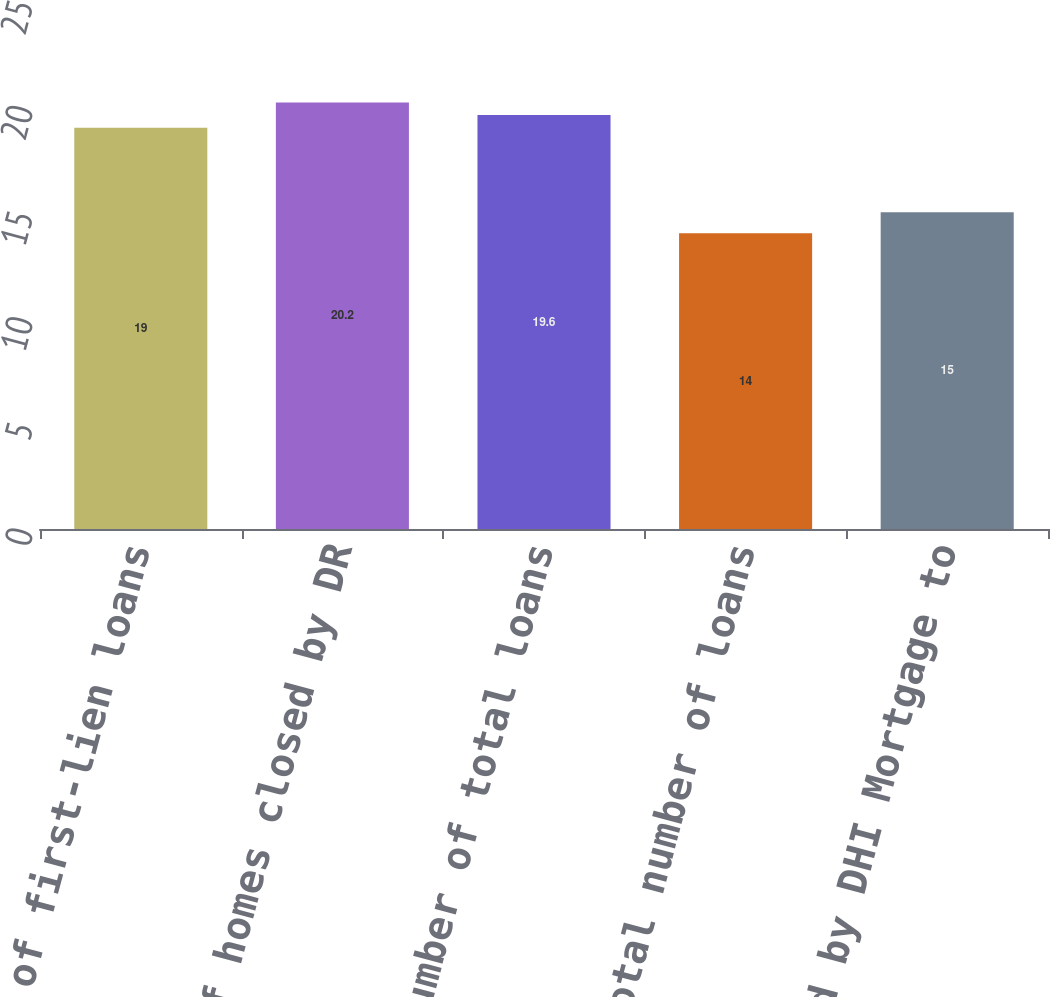<chart> <loc_0><loc_0><loc_500><loc_500><bar_chart><fcel>Number of first-lien loans<fcel>Number of homes closed by DR<fcel>Number of total loans<fcel>Total number of loans<fcel>Loans sold by DHI Mortgage to<nl><fcel>19<fcel>20.2<fcel>19.6<fcel>14<fcel>15<nl></chart> 